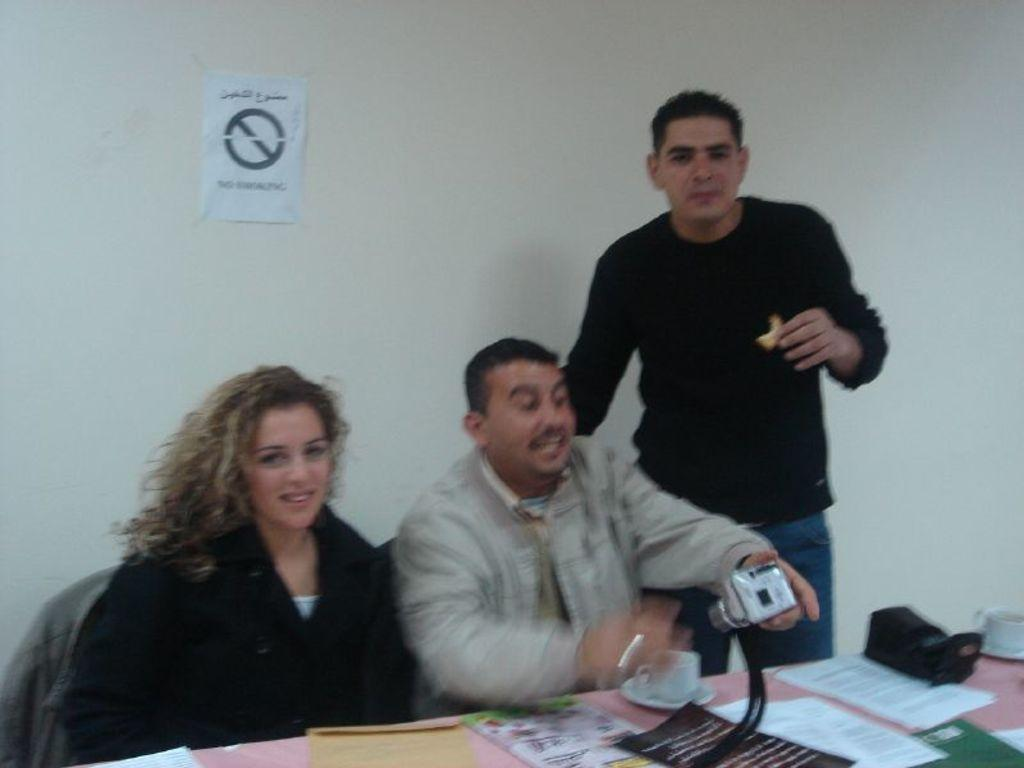How many people are in the image? There are two men and a woman in the image, making a total of three people. What are the positions of the people in the image? Two of them are sitting, and one person is standing. What is the standing person holding? The standing person is holding a camera. What type of mine can be seen in the background of the image? There is no mine present in the image; it features three people, two of whom are sitting and one standing with a camera. 